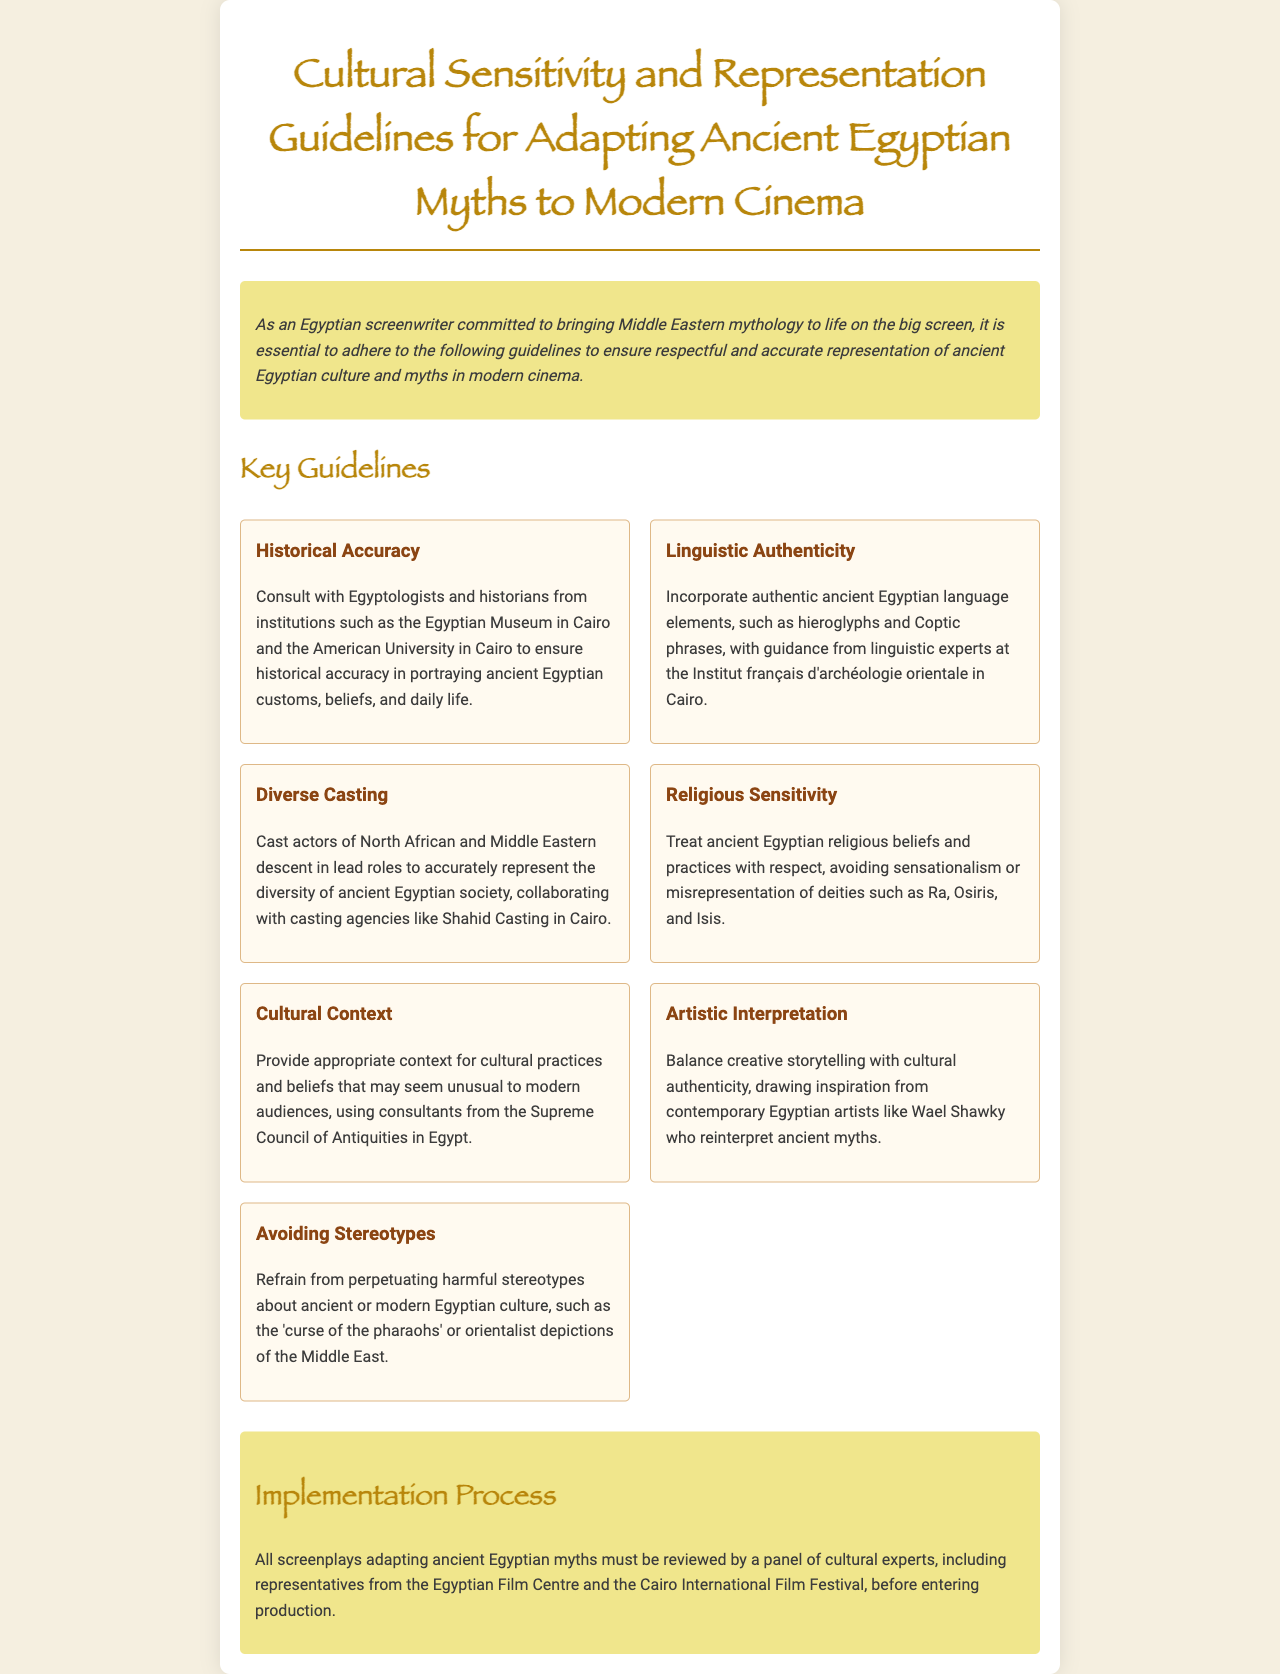What is the title of the document? The title of the document is found in the header section, indicating its main focus on cultural sensitivity and representation.
Answer: Cultural Sensitivity and Representation Guidelines for Adapting Ancient Egyptian Myths to Modern Cinema Who should consultants be for historical accuracy? The document specifies institutions and individuals that should be consulted for historical accuracy in representing ancient Egypt.
Answer: Egyptologists and historians What is one element to incorporate for linguistic authenticity? The document lists specific ancient language elements that should be used for authenticity, which include both written and spoken forms.
Answer: Hieroglyphs Which agency is suggested for casting actors? One of the guidelines recommends a casting agency known for its cultural understanding in the region.
Answer: Shahid Casting What number of guidelines is included under Key Guidelines? The document enumerates specific guidelines section under Key Guidelines, and we can count how many are mentioned there.
Answer: Seven Why is religious sensitivity important in the adaptation process? The document outlines that treating ancient religious beliefs respectfully is crucial to avoid misrepresentation and maintain cultural integrity.
Answer: To avoid sensationalism or misrepresentation Who reviews the screenplays before production? The document specifies the panel responsible for overseeing the screenplays, which includes a cultural representative body.
Answer: A panel of cultural experts What is a key artistic interpretation suggested in the guidelines? The guidelines promote an artistic approach that balances creativity with cultural authenticity based on inspiration from contemporary artists.
Answer: Inspiration from contemporary Egyptian artists like Wael Shawky 